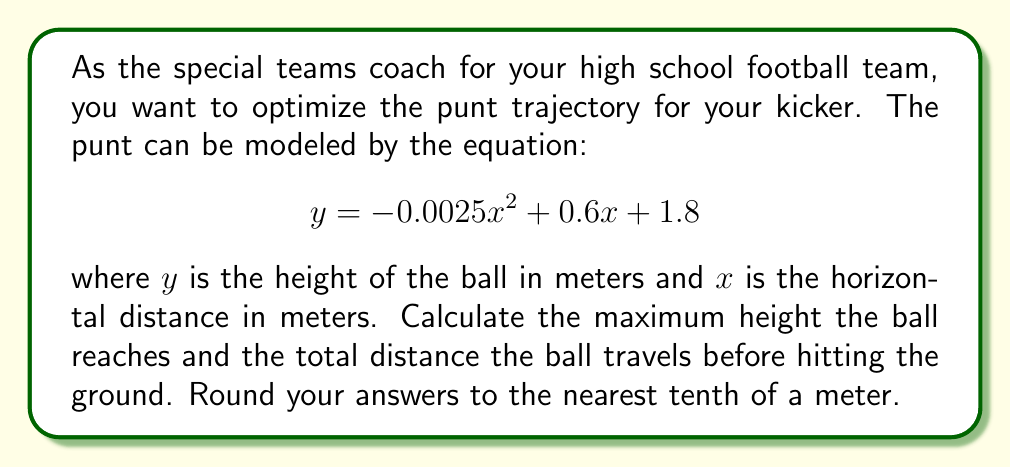Solve this math problem. To solve this problem, we'll follow these steps:

1. Find the maximum height:
   The maximum height occurs at the vertex of the parabola. We can find this using the formula $x = -\frac{b}{2a}$ for a quadratic equation in the form $ax^2 + bx + c$.

   $a = -0.0025$, $b = 0.6$

   $x = -\frac{0.6}{2(-0.0025)} = 120$ meters

   To find the maximum height, we substitute this $x$ value into the original equation:

   $y = -0.0025(120)^2 + 0.6(120) + 1.8$
   $y = -36 + 72 + 1.8 = 37.8$ meters

2. Find the total distance:
   The ball hits the ground when $y = 0$. We can solve this by finding the roots of the quadratic equation:

   $0 = -0.0025x^2 + 0.6x + 1.8$

   Using the quadratic formula $x = \frac{-b \pm \sqrt{b^2 - 4ac}}{2a}$:

   $x = \frac{-0.6 \pm \sqrt{0.6^2 - 4(-0.0025)(1.8)}}{2(-0.0025)}$

   $x = \frac{-0.6 \pm \sqrt{0.36 + 0.018}}{-0.005}$

   $x = \frac{-0.6 \pm \sqrt{0.378}}{-0.005}$

   $x = \frac{-0.6 \pm 0.6148}{-0.005}$

   This gives us two solutions:
   $x_1 = \frac{-0.6 + 0.6148}{-0.005} = -2.96$ (not relevant as it's negative)
   $x_2 = \frac{-0.6 - 0.6148}{-0.005} = 242.96$ meters

   The positive solution, 242.96 meters, represents the total distance traveled.
Answer: Maximum height: 37.8 meters
Total distance: 243.0 meters 